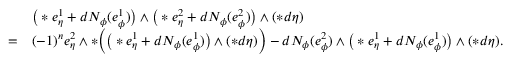Convert formula to latex. <formula><loc_0><loc_0><loc_500><loc_500>\begin{array} { r l } & { \left ( \ast e _ { \eta } ^ { 1 } + d N _ { \phi } ( e _ { \phi } ^ { 1 } ) \right ) \wedge \left ( \ast e _ { \eta } ^ { 2 } + d N _ { \phi } ( e _ { \phi } ^ { 2 } ) \right ) \wedge ( \ast d \eta ) } \\ { = } & { ( - 1 ) ^ { n } e _ { \eta } ^ { 2 } \wedge \ast \left ( \left ( \ast e _ { \eta } ^ { 1 } + d N _ { \phi } ( e _ { \phi } ^ { 1 } ) \right ) \wedge ( \ast d \eta ) \right ) - d N _ { \phi } ( e _ { \phi } ^ { 2 } ) \wedge \left ( \ast e _ { \eta } ^ { 1 } + d N _ { \phi } ( e _ { \phi } ^ { 1 } ) \right ) \wedge ( \ast d \eta ) . } \end{array}</formula> 